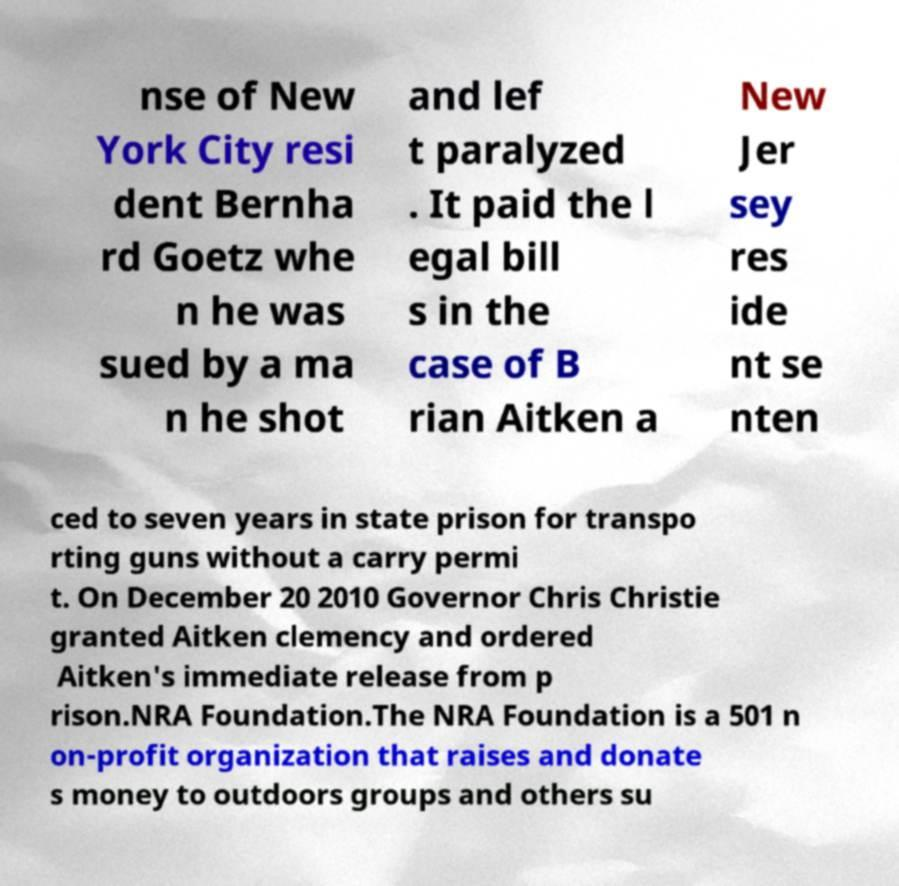Could you extract and type out the text from this image? nse of New York City resi dent Bernha rd Goetz whe n he was sued by a ma n he shot and lef t paralyzed . It paid the l egal bill s in the case of B rian Aitken a New Jer sey res ide nt se nten ced to seven years in state prison for transpo rting guns without a carry permi t. On December 20 2010 Governor Chris Christie granted Aitken clemency and ordered Aitken's immediate release from p rison.NRA Foundation.The NRA Foundation is a 501 n on-profit organization that raises and donate s money to outdoors groups and others su 